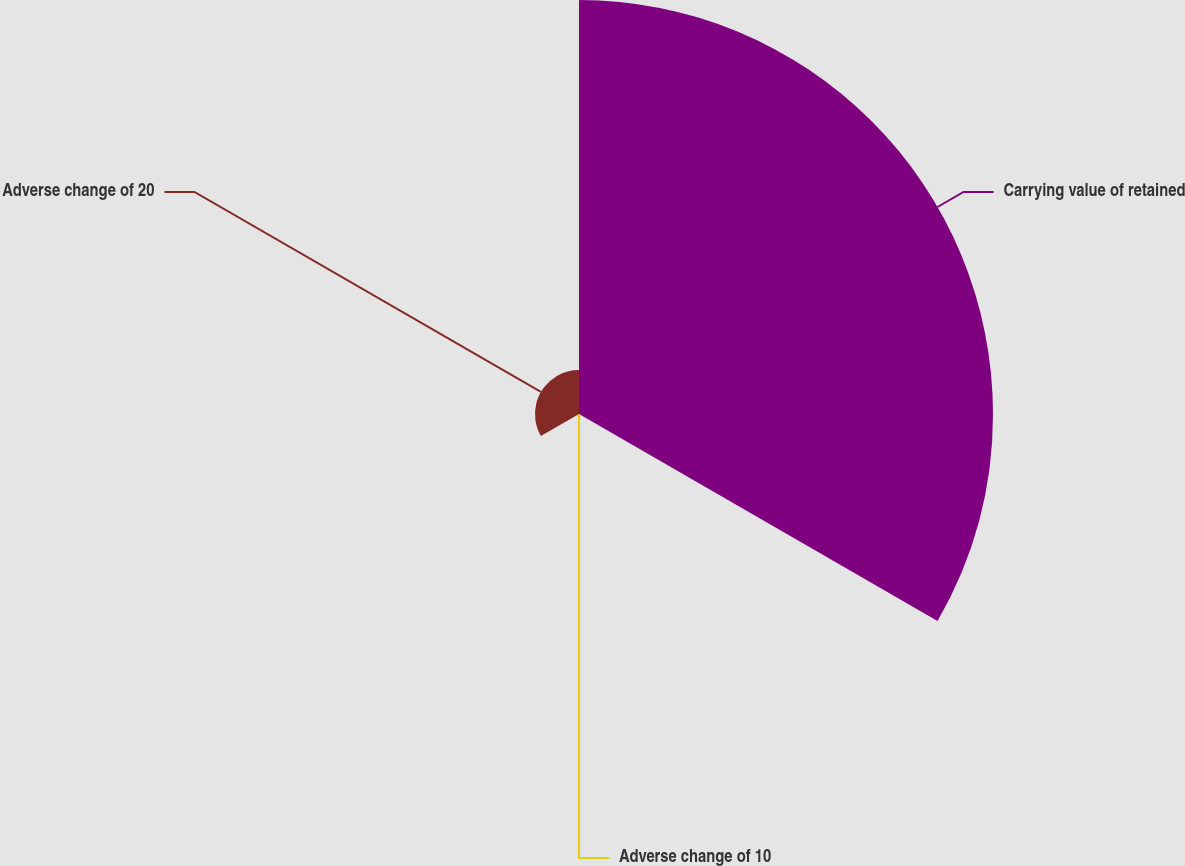Convert chart. <chart><loc_0><loc_0><loc_500><loc_500><pie_chart><fcel>Carrying value of retained<fcel>Adverse change of 10<fcel>Adverse change of 20<nl><fcel>89.82%<fcel>0.63%<fcel>9.55%<nl></chart> 